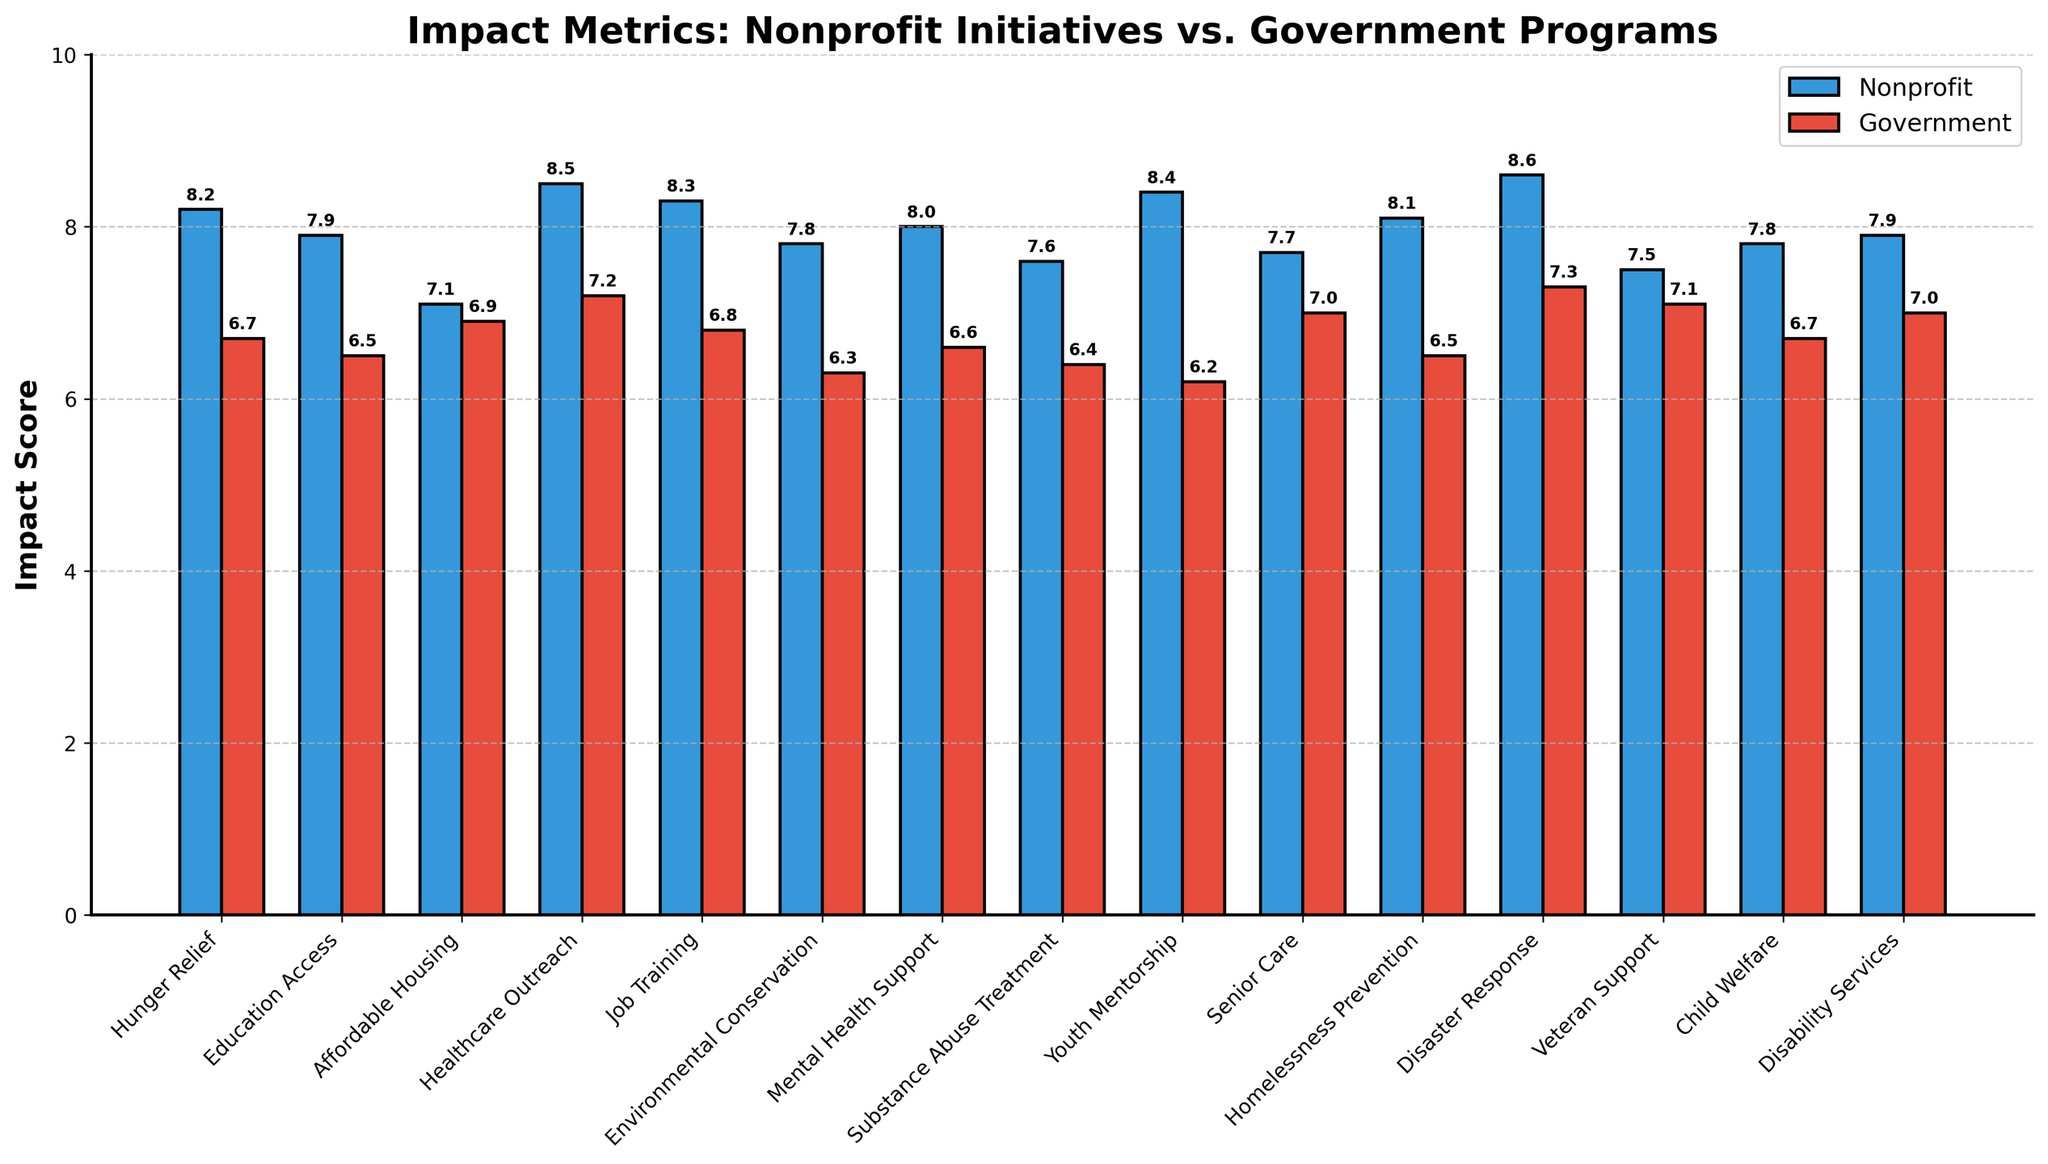Which program shows the greatest difference in impact scores between nonprofit initiatives and government programs? The greatest difference can be identified by calculating the differences between nonprofit and government scores for each program. The "Youth Mentorship" program has the most significant difference: Nonprofit (8.4) - Government (6.2) = 2.2.
Answer: Youth Mentorship Which three programs have the highest impact scores for nonprofit initiatives? The three programs with the highest nonprofit impact scores by inspection are Disaster Response (8.6), Healthcare Outreach (8.5), and Youth Mentorship (8.4).
Answer: Disaster Response, Healthcare Outreach, Youth Mentorship What is the average impact score for government programs across all key social areas? Sum all government impact scores and divide by the number of programs: (6.7 + 6.5 + 6.9 + 7.2 + 6.8 + 6.3 + 6.6 + 6.4 + 6.2 + 7.0 + 6.5 + 7.3 + 7.1 + 6.7 + 7.0) / 15 = 6.76.
Answer: 6.76 Which program(s) have a higher government impact score than their nonprofit counterpart? By comparing values, Affordable Housing (Government: 6.9, Nonprofit: 7.1) and Senior Care (Government: 7.0, Nonprofit: 7.7) are the only programs where the government score is not higher. No programs have higher government scores.
Answer: None Is the difference in impact scores between nonprofit and government programs generally consistent across different key social areas? Check consistency by examining the differences between nonprofit and government scores for each category. Most programs show a positive difference favoring nonprofits by a relatively consistent margin, typically around 1-2 points.
Answer: Yes, generally consistent Which program has the smallest difference in impact scores between nonprofit initiatives and government programs? The smallest difference is found by inspecting the differences between nonprofit and government scores. The "Affordable Housing" program has the smallest difference: Nonprofit (7.1) - Government (6.9) = 0.2.
Answer: Affordable Housing For Mental Health Support, how much higher is the nonprofit impact score compared to the government impact score? Look at the bars for Mental Health Support: Nonprofit (8.0) and Government (6.6). The difference is 8.0 - 6.6 = 1.4.
Answer: 1.4 Which programs have an impact score above 8 for nonprofit initiatives? Visually identify programs with nonprofit scores above 8: Hunger Relief (8.2), Healthcare Outreach (8.5), Job Training (8.3), Youth Mentorship (8.4), Disaster Response (8.6), and Homelessness Prevention (8.1).
Answer: Hunger Relief, Healthcare Outreach, Job Training, Youth Mentorship, Disaster Response, Homelessness Prevention What is the visual difference between bars representing nonprofit and government scores for Job Training? For Job Training, the nonprofit bar is taller and colored blue, while the government bar is shorter and colored red. The visual gap is evident and approximately 1.5 units in height on the plot.
Answer: Nonprofit taller and blue, Government shorter and red Which program shows the highest impact score for government programs? By scanning the heights of government impact bars, Disaster Response scores the highest at 7.3.
Answer: Disaster Response 